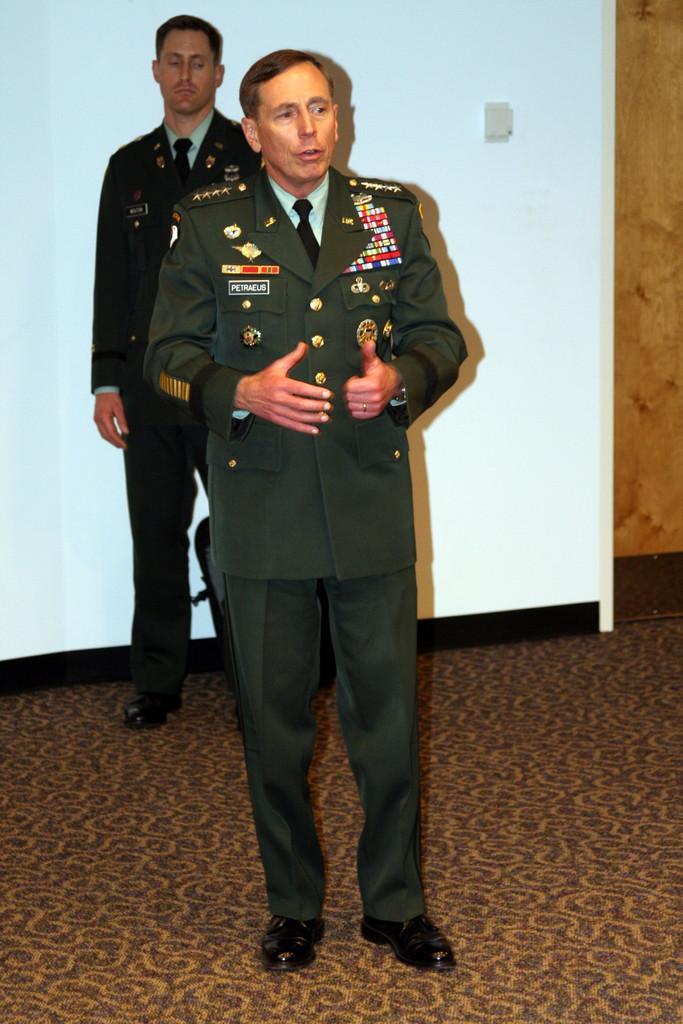Can you describe this image briefly? In this image we can see one white board near the wall in the background, one object attached to the whiteboard, one black object near the white board, one carpet on the floor, one man in army service uniform standing near the white board, one man in army service uniform standing and talking in the middle of the image. 